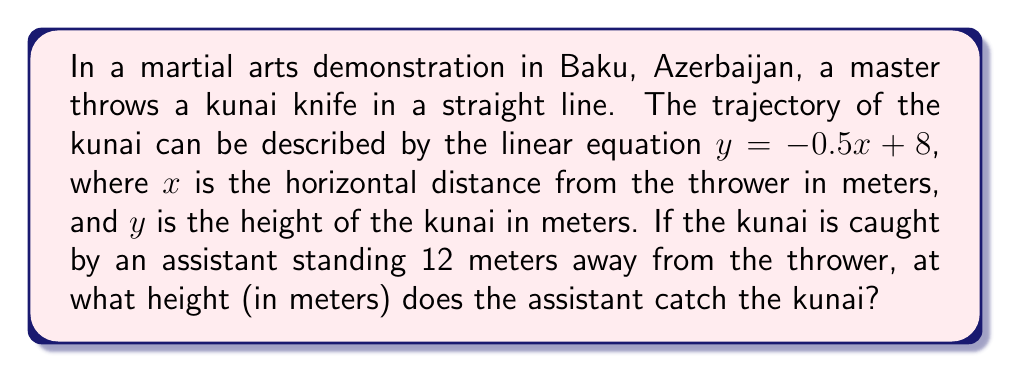Provide a solution to this math problem. To solve this problem, we need to use the given linear equation and find the value of $y$ when $x = 12$. Let's follow these steps:

1. The linear equation describing the kunai's trajectory is:
   $y = -0.5x + 8$

2. We know that the assistant is standing 12 meters away from the thrower, so $x = 12$.

3. Let's substitute $x = 12$ into the equation:
   $y = -0.5(12) + 8$

4. Now, let's solve this equation:
   $y = -6 + 8$
   $y = 2$

Therefore, the assistant catches the kunai at a height of 2 meters.

[asy]
unitsize(0.5cm);
draw((-1,0)--(13,0),arrow=Arrow(TeXHead));
draw((0,-1)--(0,9),arrow=Arrow(TeXHead));
draw((0,8)--(12,2),blue);
dot((12,2),red);
label("$x$",(13,0),SE);
label("$y$",(0,9),NW);
label("(12, 2)",(12,2),SE);
label("$y = -0.5x + 8$",(6,5),NW);
[/asy]
Answer: The assistant catches the kunai at a height of 2 meters. 